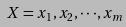<formula> <loc_0><loc_0><loc_500><loc_500>X = x _ { 1 } , x _ { 2 } , \cdot \cdot \cdot , x _ { m }</formula> 